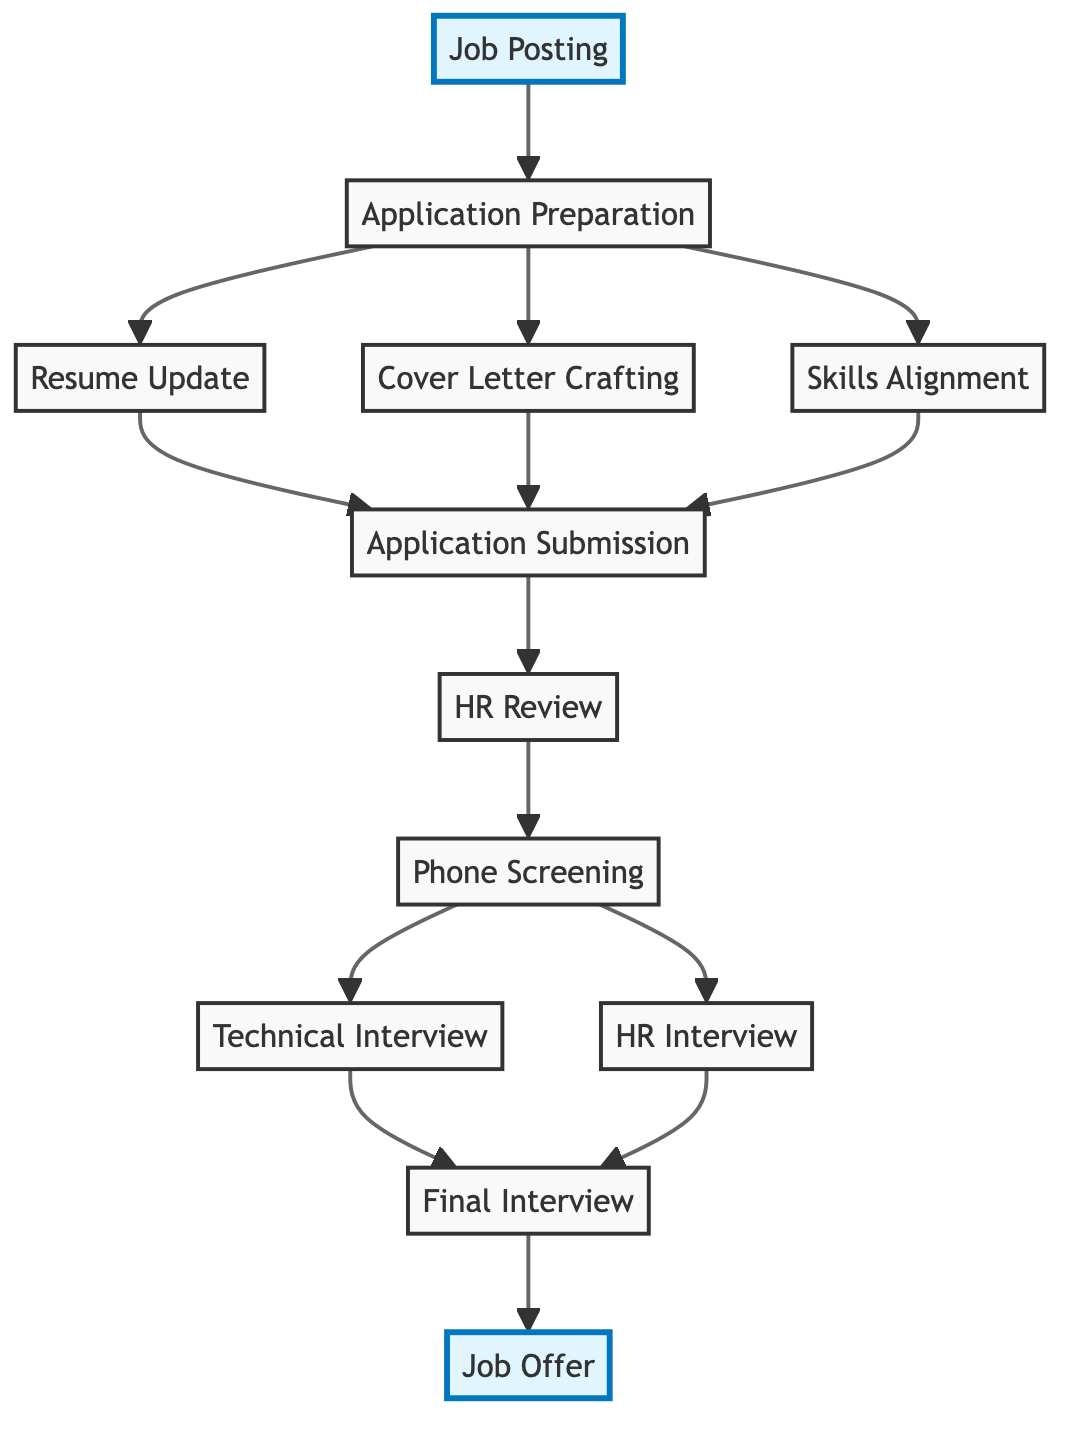What is the first step in the job search process? The diagram starts at the node labeled "Job Posting," which indicates that finding and identifying job postings is the initial step in the job search process.
Answer: Job Posting How many nodes are in the job search process diagram? The diagram contains a total of 12 nodes, representing different stages from job posting to job offer. Each node corresponds to a step in the job application and interview process.
Answer: 12 Which step comes after Application Submission? Following the "Application Submission" node, the next step according to the diagram is "HR Review," indicating that applications are reviewed by human resources after submission.
Answer: HR Review What three components are part of Application Preparation? The "Application Preparation" node branches out to three components: "Resume Update," "Cover Letter Crafting," and "Skills Alignment." Each of these contributes to preparing a complete job application.
Answer: Resume Update, Cover Letter Crafting, Skills Alignment How many steps lead to the Final Interview? There are two paths leading to the "Final Interview": one from the "Technical Interview" and another from the "HR Interview." Thus, there are two distinct steps that culminate in the final interview stage.
Answer: 2 What is the last step in the job search process? The final step represented in the diagram is the "Job Offer," showing that once all interviews are completed successfully, the next step is receiving a job offer.
Answer: Job Offer What step follows Phone Screening? The "Phone Screening" node connects to two subsequent steps: "Technical Interview" and "HR Interview." Therefore, either interview can follow the phone screening stage.
Answer: Technical Interview, HR Interview Which node has the most incoming edges? The "Application Submission" node has three incoming edges from "Resume Update," "Cover Letter Crafting," and "Skills Alignment," indicating that it is dependent on multiple preparation activities.
Answer: Application Submission What is the relationship between Resume Update and Job Offer? The diagram shows that "Resume Update" is an earlier step leading to "Application Submission," which eventually leads to the "Job Offer." The relationship is thus indirect and spans several steps in between.
Answer: Indirect 